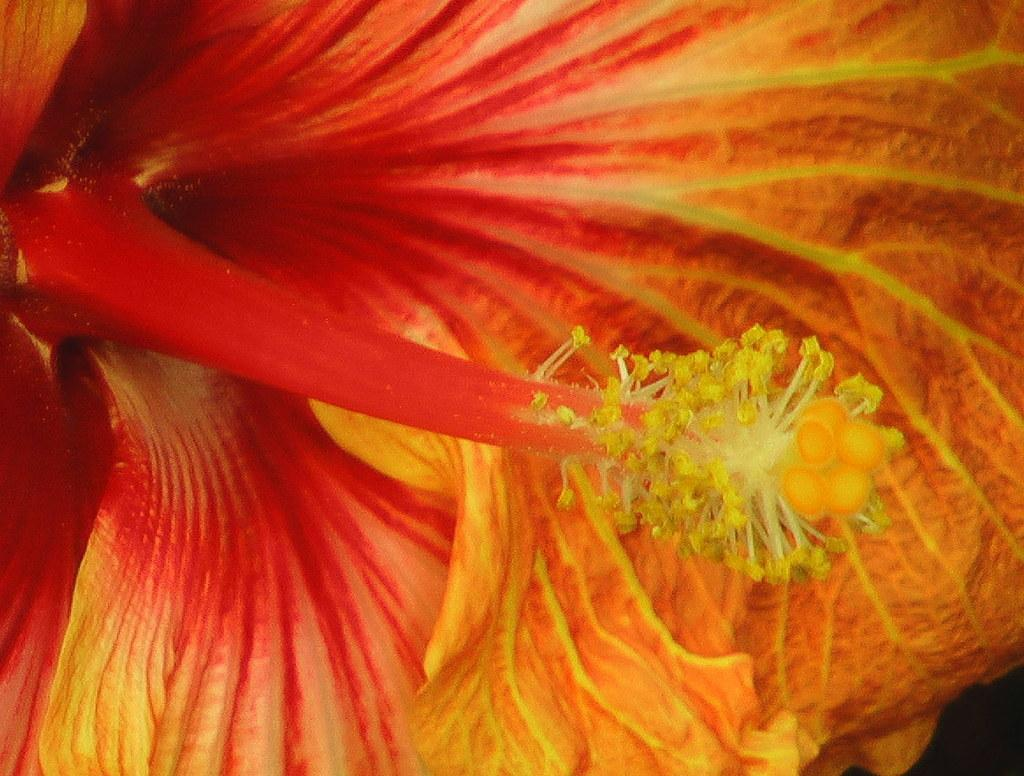What is the main subject of the image? The main subject of the image is a flower. Can you describe the colors of the flower? The flower has orange and red colors. How many boys are visible in the image? There are no boys present in the image; it features a flower with orange and red colors. What type of jam is being spread on the fireman's sandwich in the image? There is no sandwich or fireman present in the image; it features a flower with orange and red colors. 